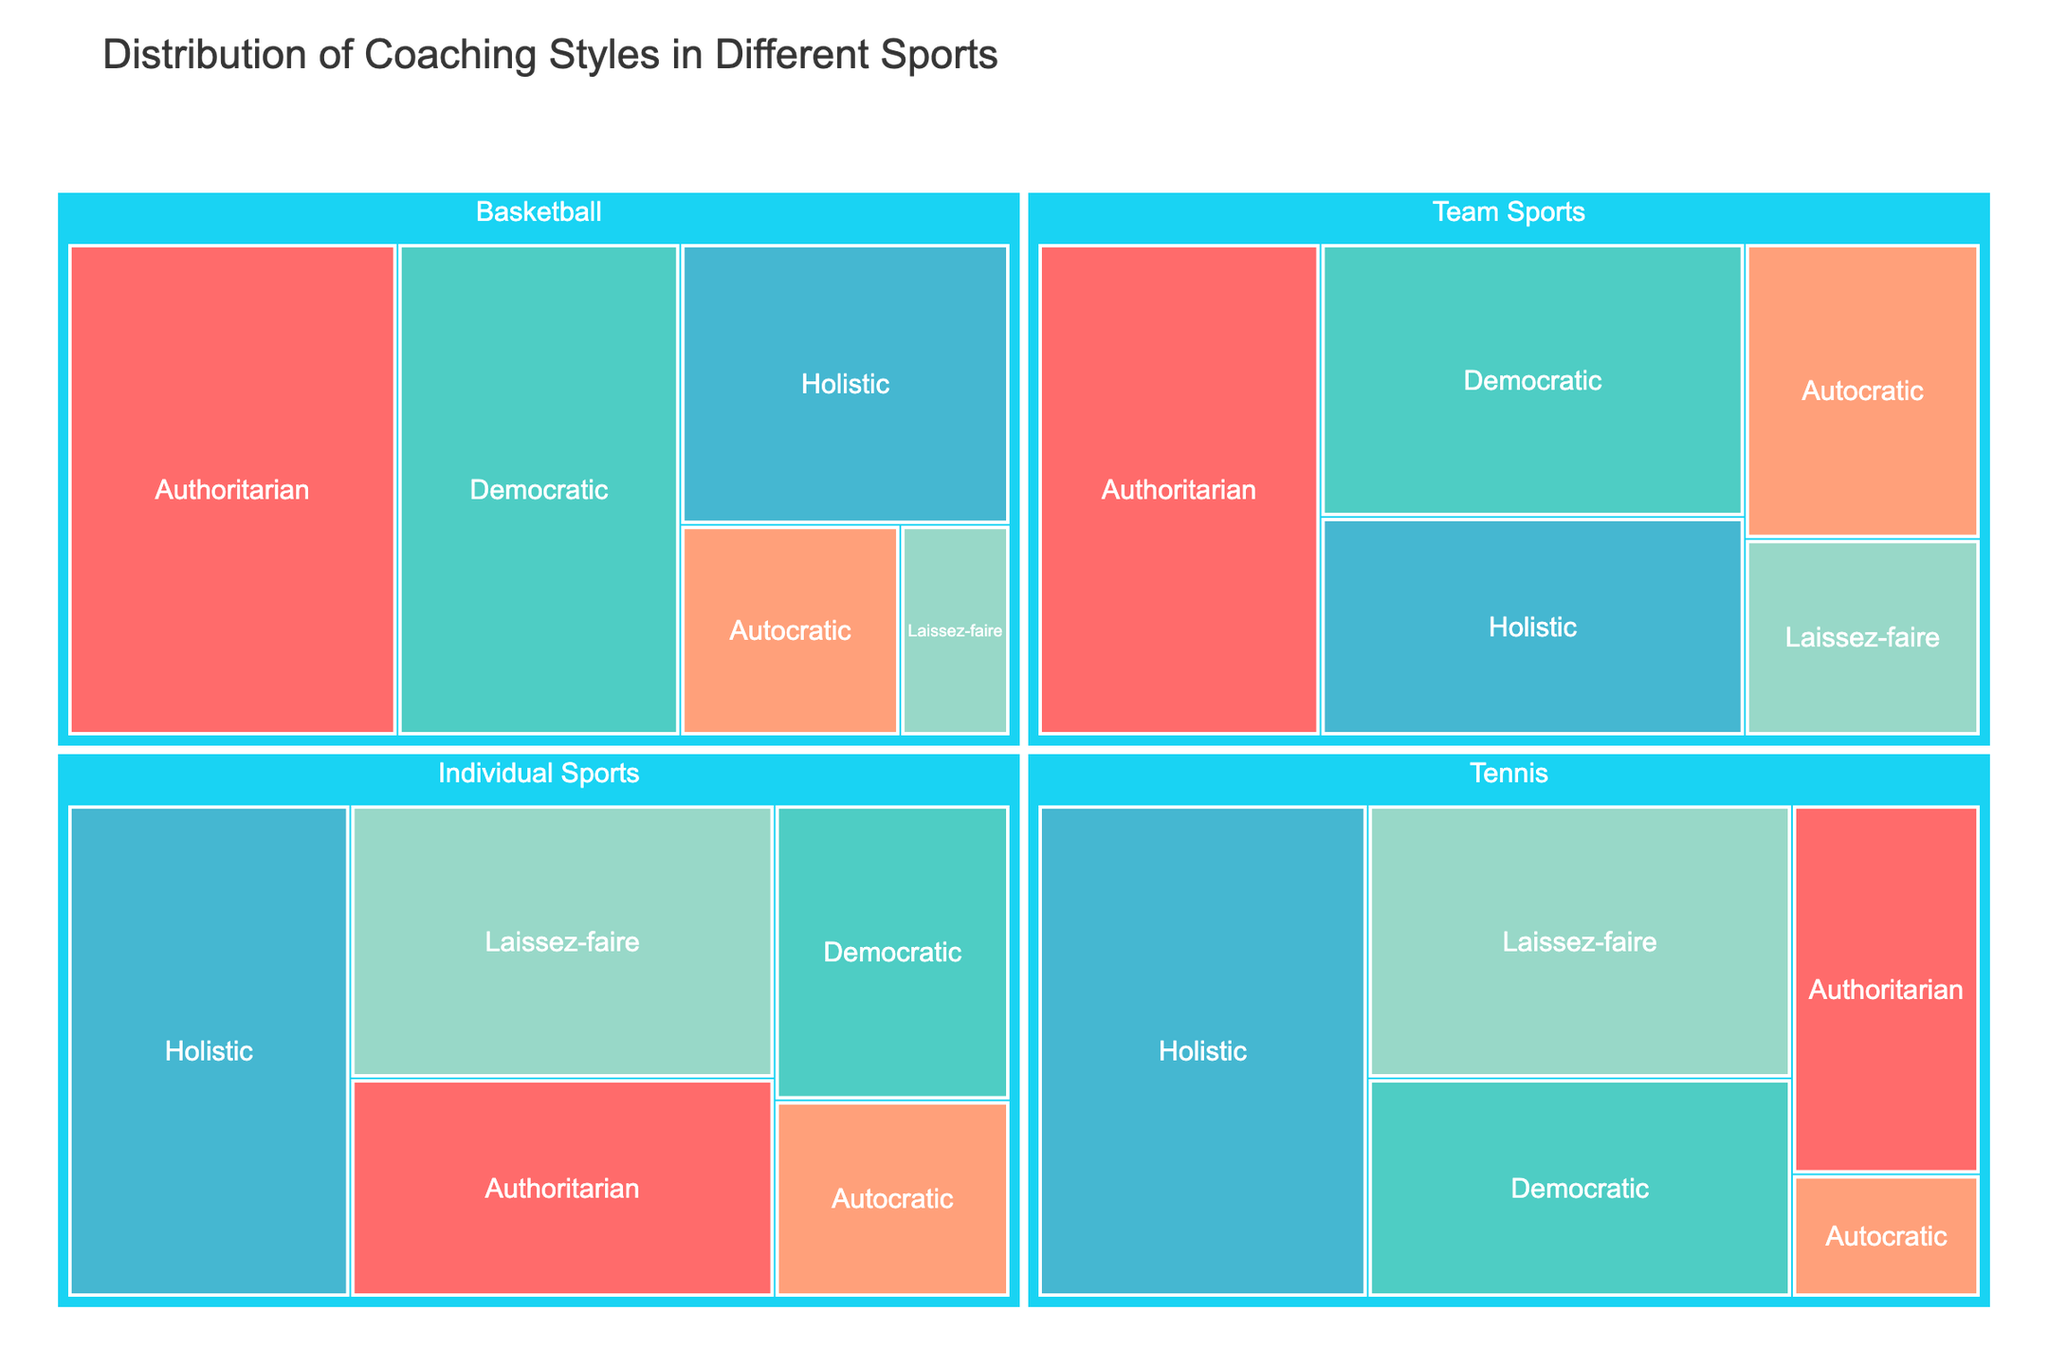What is the title of the figure? The title of the figure is located at the top and it provides a summary of what the data is about. The title reads "Distribution of Coaching Styles in Different Sports."
Answer: Distribution of Coaching Styles in Different Sports Which coaching style is most prevalent in team sports? In the treemap, identify the largest section under "Team Sports." The largest section represents the most prevalent coaching style, which in this case is "Authoritarian" with a prevalence of 30.
Answer: Authoritarian How do the prevalence of "Holistic" coaching differ between team and individual sports? Compare the sections labeled "Holistic" under both "Team Sports" and "Individual Sports." The prevalence in team sports is 20, whereas it is 30 in individual sports. Therefore, holistic coaching is more prevalent in individual sports by a difference of 10.
Answer: Holistic is more prevalent in individual sports by 10 Which sport has a higher prevalence of "Democratic" coaching style, Tennis or Basketball? Find and compare the sizes of the sections labeled "Democratic" under both "Tennis" and "Basketball." In Tennis, the prevalence is 20, whereas in Basketball it is 30. Therefore, Basketball has a higher prevalence.
Answer: Basketball What is the combined prevalence of "Laissez-faire" coaching style across all sports and categories? Add the prevalence values of "Laissez-faire" across team sports (10), individual sports (25), Basketball (5), and Tennis (25). The combined value is 10 + 25 + 5 + 25 = 65.
Answer: 65 Which coaching style is the least prevalent in basketball? In the treemap, find the smallest section under "Basketball." The smallest section represents the least prevalent coaching style, which is "Laissez-faire" with a prevalence of 5.
Answer: Laissez-faire How does the prevalence of "Authoritarian" coaching in basketball compare to that in tennis? Look at the sections labeled "Authoritarian" under both "Basketball" and "Tennis." The prevalence in Basketball is 35 and in Tennis is 15. The difference is 35 - 15 = 20, meaning it is more prevalent in Basketball by 20.
Answer: More prevalent in Basketball by 20 What is the total prevalence of "Holistic" coaching style in all categories excluding basketball and tennis? Add the prevalence values for "Holistic" in team sports (20) and individual sports (30). The total is 20 + 30 = 50.
Answer: 50 How many different coaching styles are represented in the treemap? Count the distinct coaching styles listed across all categories in the treemap. They are Authoritarian, Democratic, Holistic, Autocratic, and Laissez-faire, making a total of 5 styles.
Answer: 5 